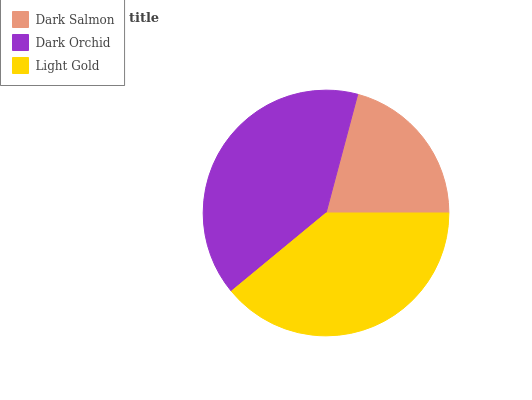Is Dark Salmon the minimum?
Answer yes or no. Yes. Is Dark Orchid the maximum?
Answer yes or no. Yes. Is Light Gold the minimum?
Answer yes or no. No. Is Light Gold the maximum?
Answer yes or no. No. Is Dark Orchid greater than Light Gold?
Answer yes or no. Yes. Is Light Gold less than Dark Orchid?
Answer yes or no. Yes. Is Light Gold greater than Dark Orchid?
Answer yes or no. No. Is Dark Orchid less than Light Gold?
Answer yes or no. No. Is Light Gold the high median?
Answer yes or no. Yes. Is Light Gold the low median?
Answer yes or no. Yes. Is Dark Orchid the high median?
Answer yes or no. No. Is Dark Orchid the low median?
Answer yes or no. No. 